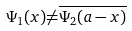<formula> <loc_0><loc_0><loc_500><loc_500>\Psi _ { 1 } ( x ) { \ne } \overline { \Psi _ { 2 } ( a - x ) }</formula> 